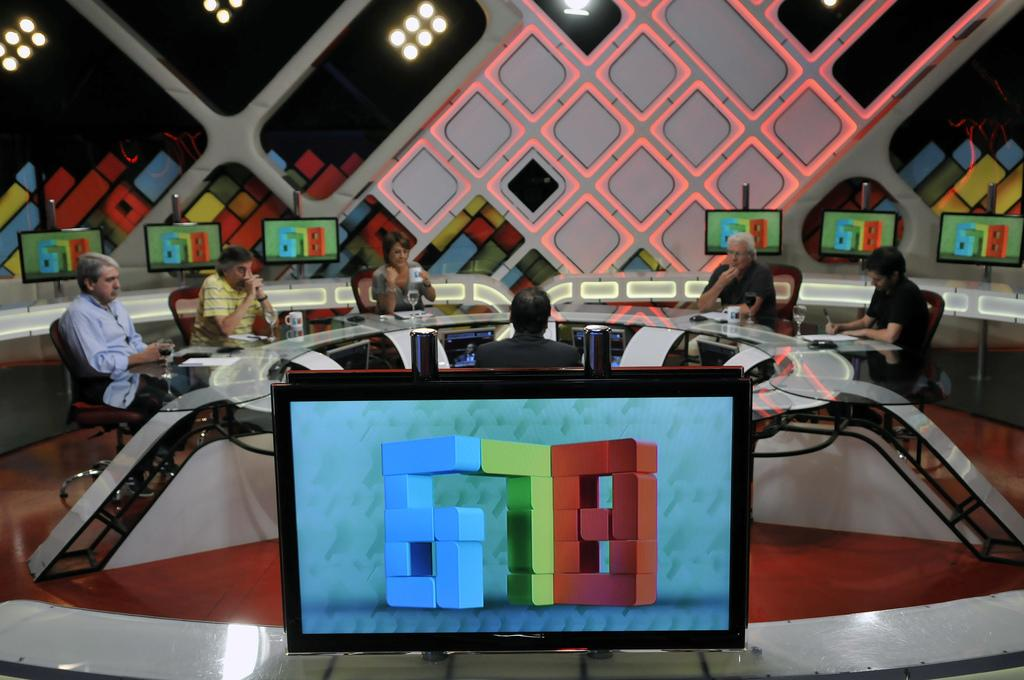<image>
Summarize the visual content of the image. Several displays that have the number 678 on them. 